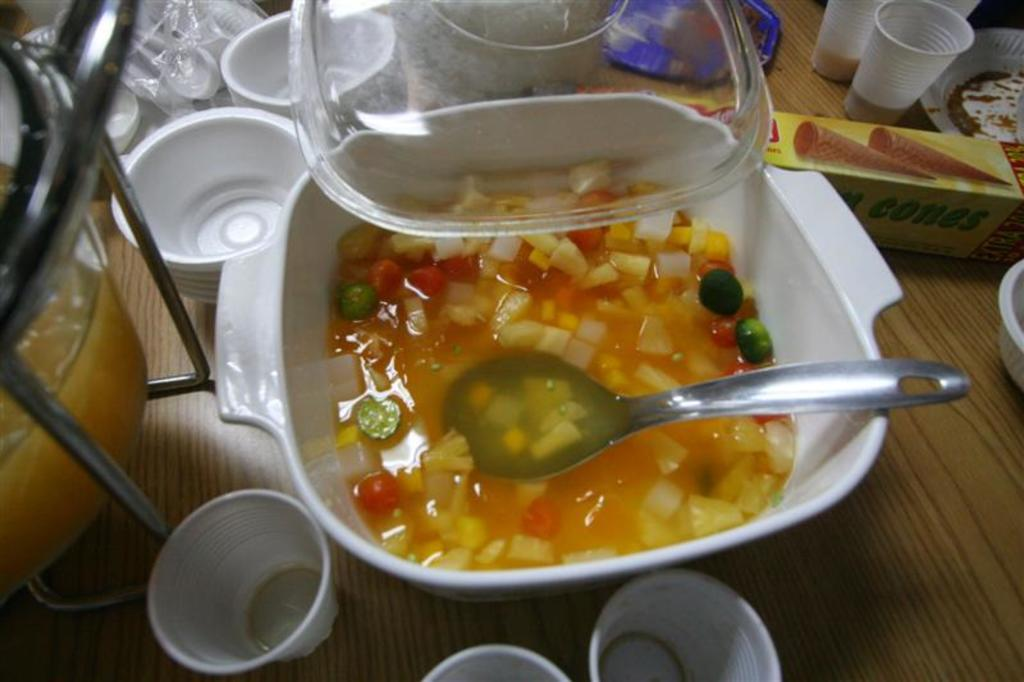What is in the bowl that is visible in the image? There is a bowl with soup in the image. What utensil is present in the image? There is a spoon in the image. What type of containers are visible in the image? There are glasses and cups in the image. What type of structure is present in the image? There is a stand in the image. What type of cover is present in the image? There is a lid in the image. What type of storage container is present in the image? There is a box in the image. What is the surface on which the objects are placed in the image? The surface is a wooden surface. How many bikes are parked on the floor in the image? There are no bikes present in the image. What type of parcel is being delivered in the image? There is no parcel delivery depicted in the image. 